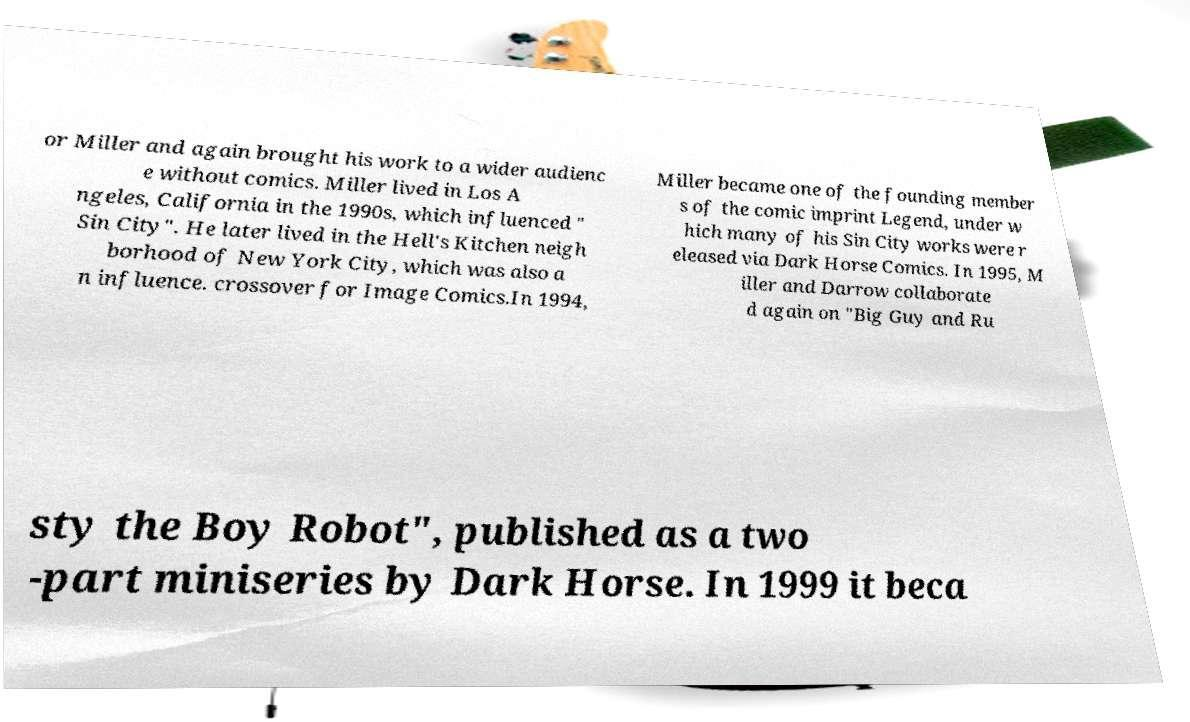Can you accurately transcribe the text from the provided image for me? or Miller and again brought his work to a wider audienc e without comics. Miller lived in Los A ngeles, California in the 1990s, which influenced " Sin City". He later lived in the Hell's Kitchen neigh borhood of New York City, which was also a n influence. crossover for Image Comics.In 1994, Miller became one of the founding member s of the comic imprint Legend, under w hich many of his Sin City works were r eleased via Dark Horse Comics. In 1995, M iller and Darrow collaborate d again on "Big Guy and Ru sty the Boy Robot", published as a two -part miniseries by Dark Horse. In 1999 it beca 